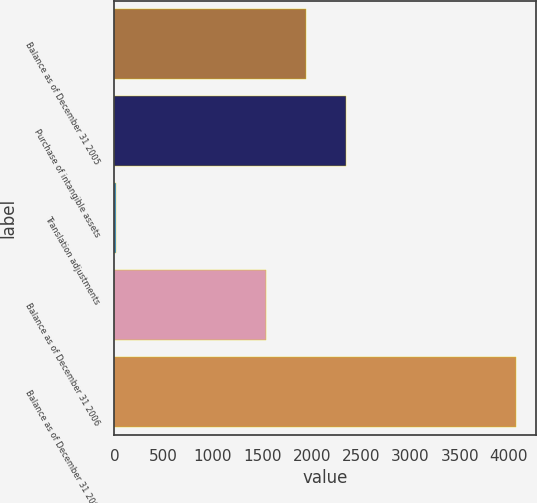Convert chart. <chart><loc_0><loc_0><loc_500><loc_500><bar_chart><fcel>Balance as of December 31 2005<fcel>Purchase of intangible assets<fcel>Translation adjustments<fcel>Balance as of December 31 2006<fcel>Balance as of December 31 2007<nl><fcel>1946<fcel>2352<fcel>15<fcel>1540<fcel>4075<nl></chart> 